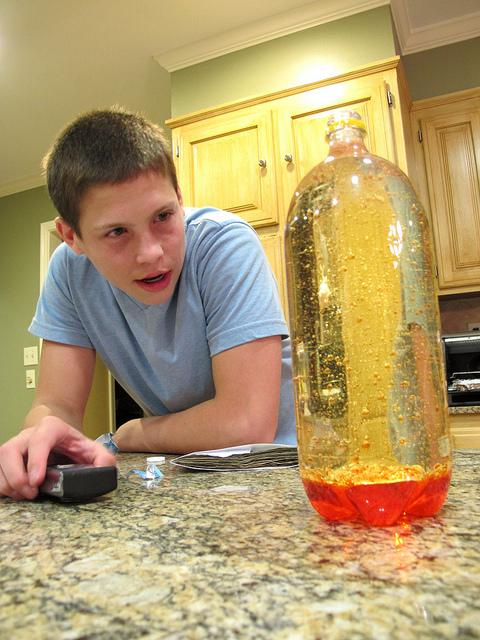What has the boy made using the bottle? Please explain your reasoning. lava lamp. The bottle contains oil and red food coloring. 